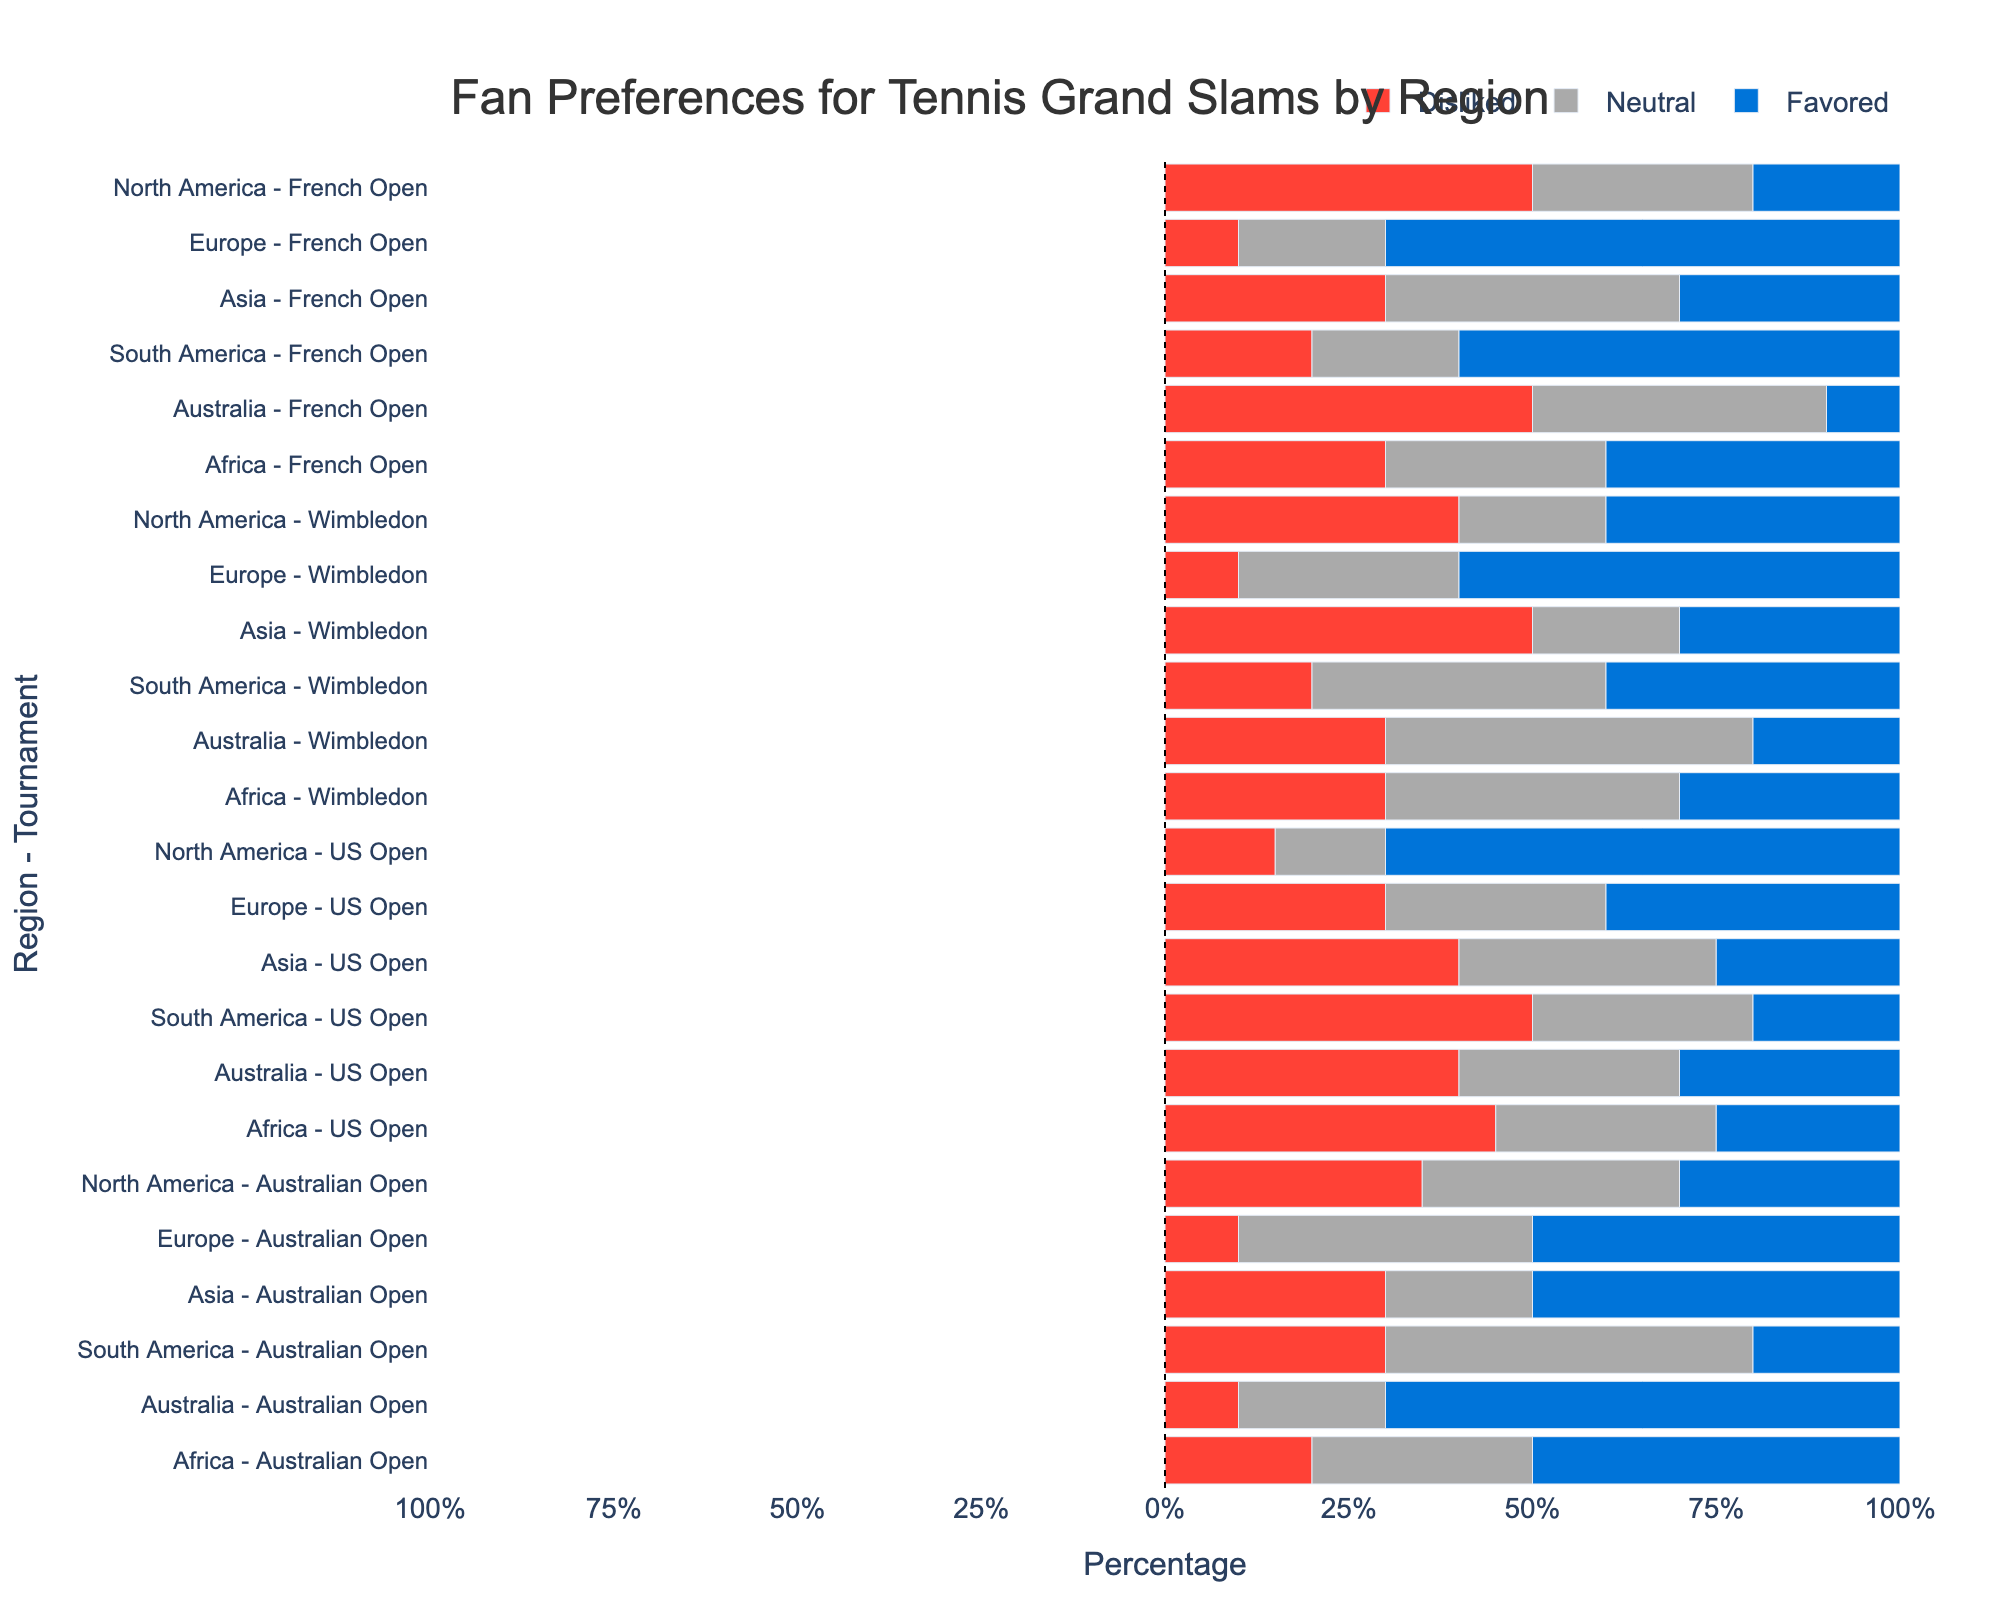Which region favors Wimbledon the most? By examining the bar segments for "Favored" preference, the tallest bar is in Europe for Wimbledon.
Answer: Europe Which tournament has the highest percentage of being "Disliked" in North America? Comparing the "Disliked" bar segments for North America across tournaments, the French Open has the tallest bar.
Answer: French Open How does the "Neutral" preference for the US Open compare between North America and Europe? In North America, the "Neutral" bar for US Open is 15%. In Europe, it is 30%. So, North America's "Neutral" preference for the US Open is lower than Europe's.
Answer: North America's is lower What is the difference in "Favored" preferences for the Australian Open between Europe and Australia? Europe's "Favored" for the Australian Open is 50%. Australia's is 70%. The difference is 70% - 50% = 20%.
Answer: 20% Which region has the most "Neutral" preferences for tournaments overall? By visually summing the height of the "Neutral" bar segments across all tournaments, Australia appears to have the highest bars in the majority of tournaments, especially notable for Wimbledon, French Open, and US Open.
Answer: Australia For which tournament does Asia show the least "Disliked" preference? For Asia, the "Disliked" bar is the smallest for the Australian Open at 30%.
Answer: Australian Open Which region shows the strongest negative sentiment (i.e., highest "Disliked" percentage) towards any tournament, and which tournament is it? The tallest "Disliked" bar is for North America towards the French Open at 50%.
Answer: North America, French Open Compare the "Favored" preferences for the French Open between South America and Africa. South America has a 60% "Favored" preference for the French Open, while Africa has 40%. South America favors the French Open more than Africa.
Answer: South America What is the combined "Disliked" percentage for Wimbledon from all regions? Sum up the "Disliked" percentages for Wimbledon across all regions: North America (40%) + Europe (10%) + Asia (50%) + South America (20%) + Australia (30%) + Africa (30%) = 180%.
Answer: 180% Which Grand Slam is favored the least by fans in North America? In North America, the lowest "Favored" percentage is for the French Open at 20%.
Answer: French Open 